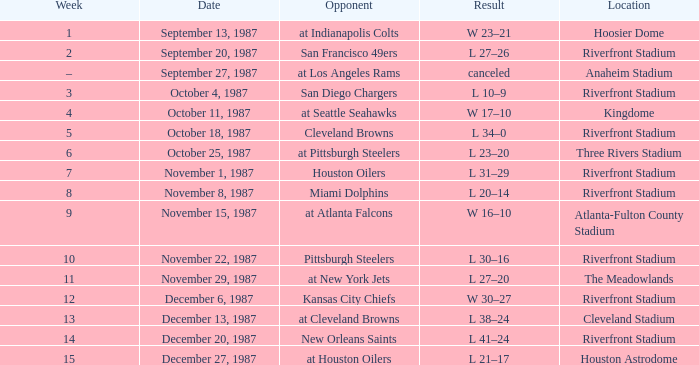What was the outcome of the match at the riverfront stadium following week 8? L 20–14. 